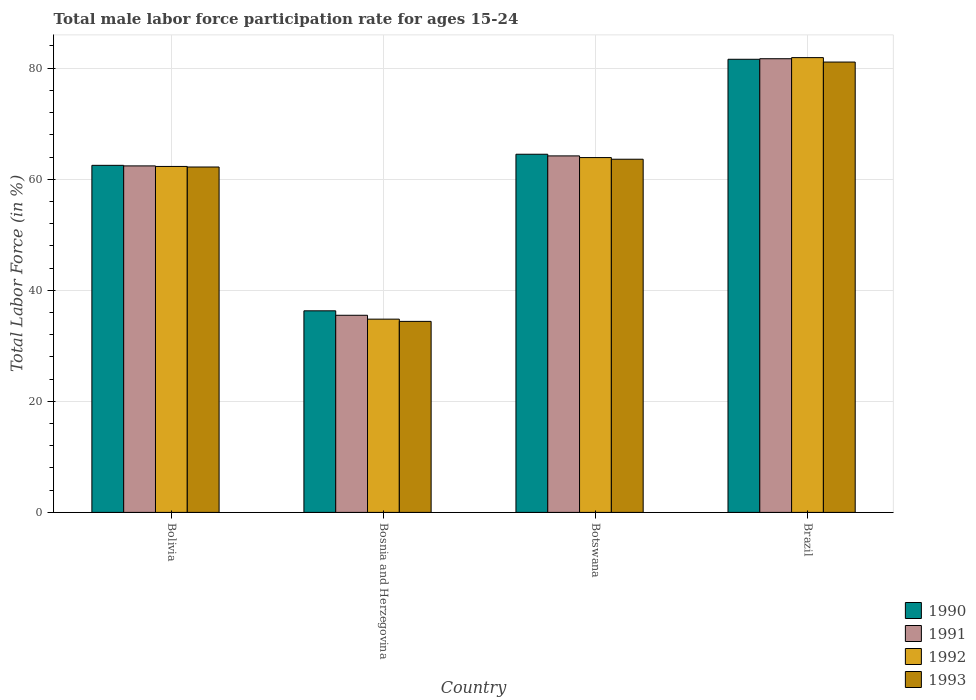How many groups of bars are there?
Ensure brevity in your answer.  4. Are the number of bars per tick equal to the number of legend labels?
Offer a very short reply. Yes. How many bars are there on the 2nd tick from the right?
Your answer should be compact. 4. What is the label of the 2nd group of bars from the left?
Provide a succinct answer. Bosnia and Herzegovina. In how many cases, is the number of bars for a given country not equal to the number of legend labels?
Offer a very short reply. 0. What is the male labor force participation rate in 1993 in Bolivia?
Keep it short and to the point. 62.2. Across all countries, what is the maximum male labor force participation rate in 1993?
Offer a very short reply. 81.1. Across all countries, what is the minimum male labor force participation rate in 1990?
Offer a terse response. 36.3. In which country was the male labor force participation rate in 1991 minimum?
Ensure brevity in your answer.  Bosnia and Herzegovina. What is the total male labor force participation rate in 1990 in the graph?
Your answer should be very brief. 244.9. What is the difference between the male labor force participation rate in 1990 in Botswana and that in Brazil?
Your answer should be very brief. -17.1. What is the difference between the male labor force participation rate in 1993 in Botswana and the male labor force participation rate in 1992 in Bosnia and Herzegovina?
Ensure brevity in your answer.  28.8. What is the average male labor force participation rate in 1992 per country?
Offer a terse response. 60.73. What is the difference between the male labor force participation rate of/in 1993 and male labor force participation rate of/in 1991 in Botswana?
Offer a terse response. -0.6. What is the ratio of the male labor force participation rate in 1990 in Bolivia to that in Bosnia and Herzegovina?
Offer a very short reply. 1.72. What is the difference between the highest and the second highest male labor force participation rate in 1992?
Provide a succinct answer. 19.6. What is the difference between the highest and the lowest male labor force participation rate in 1993?
Provide a succinct answer. 46.7. In how many countries, is the male labor force participation rate in 1992 greater than the average male labor force participation rate in 1992 taken over all countries?
Your answer should be very brief. 3. Is the sum of the male labor force participation rate in 1992 in Bolivia and Brazil greater than the maximum male labor force participation rate in 1993 across all countries?
Ensure brevity in your answer.  Yes. What does the 2nd bar from the right in Bolivia represents?
Give a very brief answer. 1992. How many bars are there?
Offer a very short reply. 16. Are all the bars in the graph horizontal?
Provide a short and direct response. No. Does the graph contain grids?
Your response must be concise. Yes. How many legend labels are there?
Ensure brevity in your answer.  4. How are the legend labels stacked?
Your answer should be very brief. Vertical. What is the title of the graph?
Provide a short and direct response. Total male labor force participation rate for ages 15-24. What is the label or title of the Y-axis?
Provide a short and direct response. Total Labor Force (in %). What is the Total Labor Force (in %) in 1990 in Bolivia?
Your answer should be compact. 62.5. What is the Total Labor Force (in %) of 1991 in Bolivia?
Ensure brevity in your answer.  62.4. What is the Total Labor Force (in %) in 1992 in Bolivia?
Give a very brief answer. 62.3. What is the Total Labor Force (in %) of 1993 in Bolivia?
Offer a terse response. 62.2. What is the Total Labor Force (in %) of 1990 in Bosnia and Herzegovina?
Offer a terse response. 36.3. What is the Total Labor Force (in %) in 1991 in Bosnia and Herzegovina?
Your answer should be very brief. 35.5. What is the Total Labor Force (in %) of 1992 in Bosnia and Herzegovina?
Your answer should be compact. 34.8. What is the Total Labor Force (in %) in 1993 in Bosnia and Herzegovina?
Provide a short and direct response. 34.4. What is the Total Labor Force (in %) in 1990 in Botswana?
Offer a very short reply. 64.5. What is the Total Labor Force (in %) of 1991 in Botswana?
Your answer should be compact. 64.2. What is the Total Labor Force (in %) in 1992 in Botswana?
Provide a succinct answer. 63.9. What is the Total Labor Force (in %) in 1993 in Botswana?
Provide a succinct answer. 63.6. What is the Total Labor Force (in %) in 1990 in Brazil?
Give a very brief answer. 81.6. What is the Total Labor Force (in %) of 1991 in Brazil?
Offer a terse response. 81.7. What is the Total Labor Force (in %) in 1992 in Brazil?
Make the answer very short. 81.9. What is the Total Labor Force (in %) of 1993 in Brazil?
Ensure brevity in your answer.  81.1. Across all countries, what is the maximum Total Labor Force (in %) of 1990?
Your answer should be compact. 81.6. Across all countries, what is the maximum Total Labor Force (in %) in 1991?
Give a very brief answer. 81.7. Across all countries, what is the maximum Total Labor Force (in %) in 1992?
Your response must be concise. 81.9. Across all countries, what is the maximum Total Labor Force (in %) of 1993?
Offer a terse response. 81.1. Across all countries, what is the minimum Total Labor Force (in %) of 1990?
Offer a very short reply. 36.3. Across all countries, what is the minimum Total Labor Force (in %) of 1991?
Your answer should be very brief. 35.5. Across all countries, what is the minimum Total Labor Force (in %) in 1992?
Ensure brevity in your answer.  34.8. Across all countries, what is the minimum Total Labor Force (in %) in 1993?
Give a very brief answer. 34.4. What is the total Total Labor Force (in %) in 1990 in the graph?
Make the answer very short. 244.9. What is the total Total Labor Force (in %) in 1991 in the graph?
Ensure brevity in your answer.  243.8. What is the total Total Labor Force (in %) in 1992 in the graph?
Make the answer very short. 242.9. What is the total Total Labor Force (in %) of 1993 in the graph?
Offer a terse response. 241.3. What is the difference between the Total Labor Force (in %) in 1990 in Bolivia and that in Bosnia and Herzegovina?
Offer a terse response. 26.2. What is the difference between the Total Labor Force (in %) in 1991 in Bolivia and that in Bosnia and Herzegovina?
Offer a terse response. 26.9. What is the difference between the Total Labor Force (in %) in 1993 in Bolivia and that in Bosnia and Herzegovina?
Provide a succinct answer. 27.8. What is the difference between the Total Labor Force (in %) in 1990 in Bolivia and that in Botswana?
Offer a terse response. -2. What is the difference between the Total Labor Force (in %) in 1991 in Bolivia and that in Botswana?
Offer a terse response. -1.8. What is the difference between the Total Labor Force (in %) in 1992 in Bolivia and that in Botswana?
Make the answer very short. -1.6. What is the difference between the Total Labor Force (in %) in 1990 in Bolivia and that in Brazil?
Give a very brief answer. -19.1. What is the difference between the Total Labor Force (in %) in 1991 in Bolivia and that in Brazil?
Provide a short and direct response. -19.3. What is the difference between the Total Labor Force (in %) of 1992 in Bolivia and that in Brazil?
Ensure brevity in your answer.  -19.6. What is the difference between the Total Labor Force (in %) in 1993 in Bolivia and that in Brazil?
Your response must be concise. -18.9. What is the difference between the Total Labor Force (in %) of 1990 in Bosnia and Herzegovina and that in Botswana?
Offer a terse response. -28.2. What is the difference between the Total Labor Force (in %) of 1991 in Bosnia and Herzegovina and that in Botswana?
Offer a terse response. -28.7. What is the difference between the Total Labor Force (in %) of 1992 in Bosnia and Herzegovina and that in Botswana?
Offer a terse response. -29.1. What is the difference between the Total Labor Force (in %) of 1993 in Bosnia and Herzegovina and that in Botswana?
Provide a short and direct response. -29.2. What is the difference between the Total Labor Force (in %) of 1990 in Bosnia and Herzegovina and that in Brazil?
Keep it short and to the point. -45.3. What is the difference between the Total Labor Force (in %) in 1991 in Bosnia and Herzegovina and that in Brazil?
Provide a succinct answer. -46.2. What is the difference between the Total Labor Force (in %) in 1992 in Bosnia and Herzegovina and that in Brazil?
Your answer should be compact. -47.1. What is the difference between the Total Labor Force (in %) in 1993 in Bosnia and Herzegovina and that in Brazil?
Offer a terse response. -46.7. What is the difference between the Total Labor Force (in %) of 1990 in Botswana and that in Brazil?
Your response must be concise. -17.1. What is the difference between the Total Labor Force (in %) of 1991 in Botswana and that in Brazil?
Give a very brief answer. -17.5. What is the difference between the Total Labor Force (in %) in 1993 in Botswana and that in Brazil?
Ensure brevity in your answer.  -17.5. What is the difference between the Total Labor Force (in %) of 1990 in Bolivia and the Total Labor Force (in %) of 1991 in Bosnia and Herzegovina?
Offer a terse response. 27. What is the difference between the Total Labor Force (in %) of 1990 in Bolivia and the Total Labor Force (in %) of 1992 in Bosnia and Herzegovina?
Keep it short and to the point. 27.7. What is the difference between the Total Labor Force (in %) in 1990 in Bolivia and the Total Labor Force (in %) in 1993 in Bosnia and Herzegovina?
Your response must be concise. 28.1. What is the difference between the Total Labor Force (in %) in 1991 in Bolivia and the Total Labor Force (in %) in 1992 in Bosnia and Herzegovina?
Make the answer very short. 27.6. What is the difference between the Total Labor Force (in %) of 1992 in Bolivia and the Total Labor Force (in %) of 1993 in Bosnia and Herzegovina?
Make the answer very short. 27.9. What is the difference between the Total Labor Force (in %) in 1990 in Bolivia and the Total Labor Force (in %) in 1992 in Botswana?
Your response must be concise. -1.4. What is the difference between the Total Labor Force (in %) of 1992 in Bolivia and the Total Labor Force (in %) of 1993 in Botswana?
Your answer should be compact. -1.3. What is the difference between the Total Labor Force (in %) of 1990 in Bolivia and the Total Labor Force (in %) of 1991 in Brazil?
Your answer should be very brief. -19.2. What is the difference between the Total Labor Force (in %) in 1990 in Bolivia and the Total Labor Force (in %) in 1992 in Brazil?
Ensure brevity in your answer.  -19.4. What is the difference between the Total Labor Force (in %) in 1990 in Bolivia and the Total Labor Force (in %) in 1993 in Brazil?
Keep it short and to the point. -18.6. What is the difference between the Total Labor Force (in %) of 1991 in Bolivia and the Total Labor Force (in %) of 1992 in Brazil?
Your response must be concise. -19.5. What is the difference between the Total Labor Force (in %) in 1991 in Bolivia and the Total Labor Force (in %) in 1993 in Brazil?
Provide a short and direct response. -18.7. What is the difference between the Total Labor Force (in %) of 1992 in Bolivia and the Total Labor Force (in %) of 1993 in Brazil?
Give a very brief answer. -18.8. What is the difference between the Total Labor Force (in %) in 1990 in Bosnia and Herzegovina and the Total Labor Force (in %) in 1991 in Botswana?
Offer a terse response. -27.9. What is the difference between the Total Labor Force (in %) of 1990 in Bosnia and Herzegovina and the Total Labor Force (in %) of 1992 in Botswana?
Offer a very short reply. -27.6. What is the difference between the Total Labor Force (in %) of 1990 in Bosnia and Herzegovina and the Total Labor Force (in %) of 1993 in Botswana?
Ensure brevity in your answer.  -27.3. What is the difference between the Total Labor Force (in %) of 1991 in Bosnia and Herzegovina and the Total Labor Force (in %) of 1992 in Botswana?
Offer a terse response. -28.4. What is the difference between the Total Labor Force (in %) of 1991 in Bosnia and Herzegovina and the Total Labor Force (in %) of 1993 in Botswana?
Offer a very short reply. -28.1. What is the difference between the Total Labor Force (in %) of 1992 in Bosnia and Herzegovina and the Total Labor Force (in %) of 1993 in Botswana?
Provide a succinct answer. -28.8. What is the difference between the Total Labor Force (in %) of 1990 in Bosnia and Herzegovina and the Total Labor Force (in %) of 1991 in Brazil?
Give a very brief answer. -45.4. What is the difference between the Total Labor Force (in %) of 1990 in Bosnia and Herzegovina and the Total Labor Force (in %) of 1992 in Brazil?
Make the answer very short. -45.6. What is the difference between the Total Labor Force (in %) of 1990 in Bosnia and Herzegovina and the Total Labor Force (in %) of 1993 in Brazil?
Your answer should be compact. -44.8. What is the difference between the Total Labor Force (in %) in 1991 in Bosnia and Herzegovina and the Total Labor Force (in %) in 1992 in Brazil?
Offer a terse response. -46.4. What is the difference between the Total Labor Force (in %) of 1991 in Bosnia and Herzegovina and the Total Labor Force (in %) of 1993 in Brazil?
Offer a very short reply. -45.6. What is the difference between the Total Labor Force (in %) in 1992 in Bosnia and Herzegovina and the Total Labor Force (in %) in 1993 in Brazil?
Give a very brief answer. -46.3. What is the difference between the Total Labor Force (in %) in 1990 in Botswana and the Total Labor Force (in %) in 1991 in Brazil?
Your response must be concise. -17.2. What is the difference between the Total Labor Force (in %) in 1990 in Botswana and the Total Labor Force (in %) in 1992 in Brazil?
Ensure brevity in your answer.  -17.4. What is the difference between the Total Labor Force (in %) of 1990 in Botswana and the Total Labor Force (in %) of 1993 in Brazil?
Keep it short and to the point. -16.6. What is the difference between the Total Labor Force (in %) in 1991 in Botswana and the Total Labor Force (in %) in 1992 in Brazil?
Offer a very short reply. -17.7. What is the difference between the Total Labor Force (in %) of 1991 in Botswana and the Total Labor Force (in %) of 1993 in Brazil?
Give a very brief answer. -16.9. What is the difference between the Total Labor Force (in %) in 1992 in Botswana and the Total Labor Force (in %) in 1993 in Brazil?
Make the answer very short. -17.2. What is the average Total Labor Force (in %) of 1990 per country?
Ensure brevity in your answer.  61.23. What is the average Total Labor Force (in %) of 1991 per country?
Offer a very short reply. 60.95. What is the average Total Labor Force (in %) in 1992 per country?
Your response must be concise. 60.73. What is the average Total Labor Force (in %) in 1993 per country?
Provide a short and direct response. 60.33. What is the difference between the Total Labor Force (in %) in 1990 and Total Labor Force (in %) in 1991 in Bolivia?
Provide a short and direct response. 0.1. What is the difference between the Total Labor Force (in %) in 1990 and Total Labor Force (in %) in 1993 in Bolivia?
Your answer should be very brief. 0.3. What is the difference between the Total Labor Force (in %) of 1990 and Total Labor Force (in %) of 1993 in Bosnia and Herzegovina?
Make the answer very short. 1.9. What is the difference between the Total Labor Force (in %) of 1991 and Total Labor Force (in %) of 1993 in Bosnia and Herzegovina?
Your answer should be compact. 1.1. What is the difference between the Total Labor Force (in %) of 1992 and Total Labor Force (in %) of 1993 in Bosnia and Herzegovina?
Keep it short and to the point. 0.4. What is the difference between the Total Labor Force (in %) of 1990 and Total Labor Force (in %) of 1992 in Botswana?
Provide a short and direct response. 0.6. What is the difference between the Total Labor Force (in %) in 1992 and Total Labor Force (in %) in 1993 in Botswana?
Your answer should be compact. 0.3. What is the difference between the Total Labor Force (in %) of 1990 and Total Labor Force (in %) of 1993 in Brazil?
Your answer should be very brief. 0.5. What is the difference between the Total Labor Force (in %) in 1991 and Total Labor Force (in %) in 1992 in Brazil?
Provide a succinct answer. -0.2. What is the difference between the Total Labor Force (in %) in 1991 and Total Labor Force (in %) in 1993 in Brazil?
Provide a short and direct response. 0.6. What is the difference between the Total Labor Force (in %) of 1992 and Total Labor Force (in %) of 1993 in Brazil?
Provide a short and direct response. 0.8. What is the ratio of the Total Labor Force (in %) of 1990 in Bolivia to that in Bosnia and Herzegovina?
Ensure brevity in your answer.  1.72. What is the ratio of the Total Labor Force (in %) of 1991 in Bolivia to that in Bosnia and Herzegovina?
Your answer should be very brief. 1.76. What is the ratio of the Total Labor Force (in %) in 1992 in Bolivia to that in Bosnia and Herzegovina?
Provide a short and direct response. 1.79. What is the ratio of the Total Labor Force (in %) in 1993 in Bolivia to that in Bosnia and Herzegovina?
Your answer should be very brief. 1.81. What is the ratio of the Total Labor Force (in %) of 1990 in Bolivia to that in Botswana?
Ensure brevity in your answer.  0.97. What is the ratio of the Total Labor Force (in %) of 1992 in Bolivia to that in Botswana?
Your answer should be compact. 0.97. What is the ratio of the Total Labor Force (in %) of 1993 in Bolivia to that in Botswana?
Your answer should be compact. 0.98. What is the ratio of the Total Labor Force (in %) in 1990 in Bolivia to that in Brazil?
Your response must be concise. 0.77. What is the ratio of the Total Labor Force (in %) of 1991 in Bolivia to that in Brazil?
Give a very brief answer. 0.76. What is the ratio of the Total Labor Force (in %) in 1992 in Bolivia to that in Brazil?
Give a very brief answer. 0.76. What is the ratio of the Total Labor Force (in %) in 1993 in Bolivia to that in Brazil?
Give a very brief answer. 0.77. What is the ratio of the Total Labor Force (in %) in 1990 in Bosnia and Herzegovina to that in Botswana?
Your answer should be compact. 0.56. What is the ratio of the Total Labor Force (in %) in 1991 in Bosnia and Herzegovina to that in Botswana?
Your answer should be compact. 0.55. What is the ratio of the Total Labor Force (in %) of 1992 in Bosnia and Herzegovina to that in Botswana?
Ensure brevity in your answer.  0.54. What is the ratio of the Total Labor Force (in %) of 1993 in Bosnia and Herzegovina to that in Botswana?
Your answer should be compact. 0.54. What is the ratio of the Total Labor Force (in %) of 1990 in Bosnia and Herzegovina to that in Brazil?
Your answer should be compact. 0.44. What is the ratio of the Total Labor Force (in %) of 1991 in Bosnia and Herzegovina to that in Brazil?
Your answer should be compact. 0.43. What is the ratio of the Total Labor Force (in %) in 1992 in Bosnia and Herzegovina to that in Brazil?
Offer a very short reply. 0.42. What is the ratio of the Total Labor Force (in %) in 1993 in Bosnia and Herzegovina to that in Brazil?
Provide a short and direct response. 0.42. What is the ratio of the Total Labor Force (in %) in 1990 in Botswana to that in Brazil?
Ensure brevity in your answer.  0.79. What is the ratio of the Total Labor Force (in %) of 1991 in Botswana to that in Brazil?
Ensure brevity in your answer.  0.79. What is the ratio of the Total Labor Force (in %) of 1992 in Botswana to that in Brazil?
Keep it short and to the point. 0.78. What is the ratio of the Total Labor Force (in %) in 1993 in Botswana to that in Brazil?
Your answer should be very brief. 0.78. What is the difference between the highest and the second highest Total Labor Force (in %) in 1991?
Your response must be concise. 17.5. What is the difference between the highest and the second highest Total Labor Force (in %) in 1992?
Provide a short and direct response. 18. What is the difference between the highest and the lowest Total Labor Force (in %) in 1990?
Keep it short and to the point. 45.3. What is the difference between the highest and the lowest Total Labor Force (in %) in 1991?
Provide a succinct answer. 46.2. What is the difference between the highest and the lowest Total Labor Force (in %) of 1992?
Offer a very short reply. 47.1. What is the difference between the highest and the lowest Total Labor Force (in %) of 1993?
Ensure brevity in your answer.  46.7. 